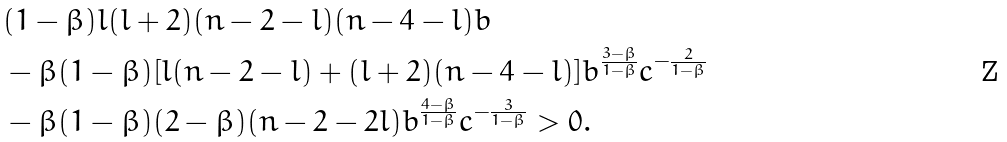<formula> <loc_0><loc_0><loc_500><loc_500>& ( 1 - \beta ) l ( l + 2 ) ( n - 2 - l ) ( n - 4 - l ) b \\ & - \beta ( 1 - \beta ) [ l ( n - 2 - l ) + ( l + 2 ) ( n - 4 - l ) ] b ^ { \frac { 3 - \beta } { 1 - \beta } } c ^ { - \frac { 2 } { 1 - \beta } } \\ & - \beta ( 1 - \beta ) ( 2 - \beta ) ( n - 2 - 2 l ) b ^ { \frac { 4 - \beta } { 1 - \beta } } c ^ { - \frac { 3 } { 1 - \beta } } > 0 .</formula> 